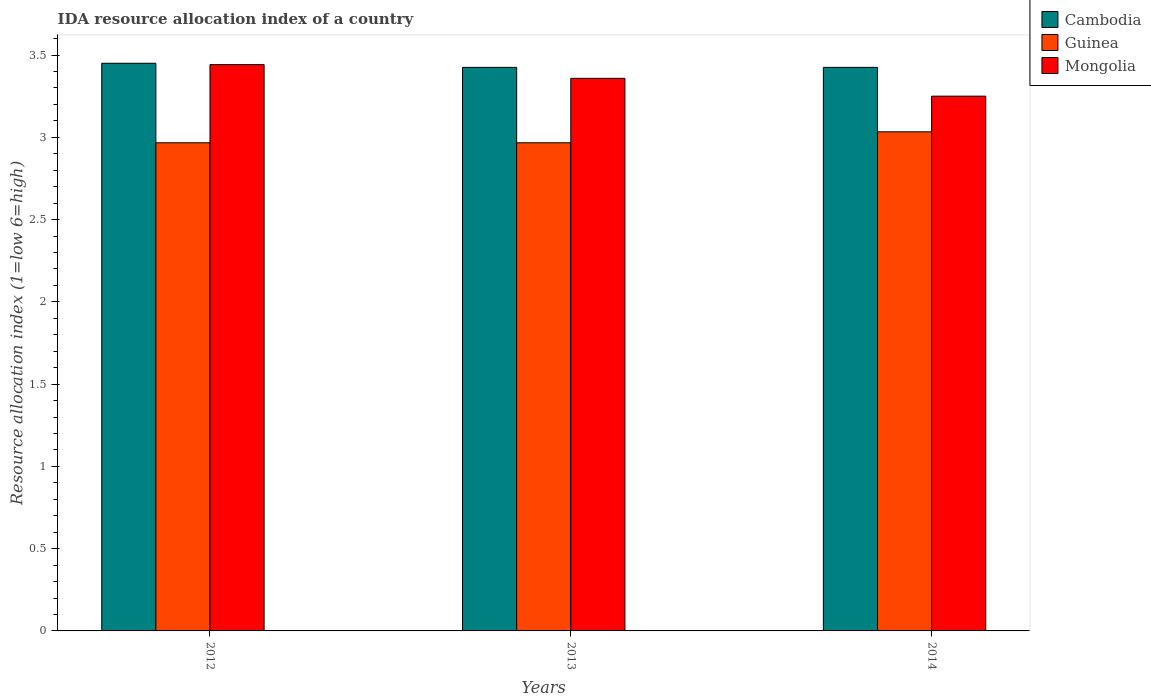How many different coloured bars are there?
Give a very brief answer. 3. Are the number of bars on each tick of the X-axis equal?
Offer a terse response. Yes. How many bars are there on the 3rd tick from the left?
Offer a terse response. 3. How many bars are there on the 2nd tick from the right?
Give a very brief answer. 3. In how many cases, is the number of bars for a given year not equal to the number of legend labels?
Your answer should be very brief. 0. What is the IDA resource allocation index in Cambodia in 2013?
Make the answer very short. 3.42. Across all years, what is the maximum IDA resource allocation index in Guinea?
Your answer should be compact. 3.03. What is the total IDA resource allocation index in Guinea in the graph?
Your response must be concise. 8.97. What is the difference between the IDA resource allocation index in Mongolia in 2012 and that in 2014?
Your answer should be compact. 0.19. What is the difference between the IDA resource allocation index in Guinea in 2014 and the IDA resource allocation index in Cambodia in 2012?
Your answer should be very brief. -0.42. What is the average IDA resource allocation index in Cambodia per year?
Your answer should be compact. 3.43. In the year 2013, what is the difference between the IDA resource allocation index in Mongolia and IDA resource allocation index in Cambodia?
Your response must be concise. -0.07. What is the ratio of the IDA resource allocation index in Guinea in 2012 to that in 2013?
Give a very brief answer. 1. Is the IDA resource allocation index in Mongolia in 2012 less than that in 2013?
Your answer should be compact. No. What is the difference between the highest and the second highest IDA resource allocation index in Mongolia?
Make the answer very short. 0.08. What is the difference between the highest and the lowest IDA resource allocation index in Guinea?
Offer a very short reply. 0.07. In how many years, is the IDA resource allocation index in Mongolia greater than the average IDA resource allocation index in Mongolia taken over all years?
Offer a terse response. 2. Is the sum of the IDA resource allocation index in Mongolia in 2013 and 2014 greater than the maximum IDA resource allocation index in Cambodia across all years?
Your answer should be very brief. Yes. What does the 2nd bar from the left in 2014 represents?
Keep it short and to the point. Guinea. What does the 1st bar from the right in 2012 represents?
Provide a short and direct response. Mongolia. Is it the case that in every year, the sum of the IDA resource allocation index in Guinea and IDA resource allocation index in Cambodia is greater than the IDA resource allocation index in Mongolia?
Provide a succinct answer. Yes. Does the graph contain grids?
Offer a very short reply. No. Where does the legend appear in the graph?
Your response must be concise. Top right. How many legend labels are there?
Offer a very short reply. 3. What is the title of the graph?
Your response must be concise. IDA resource allocation index of a country. Does "Guatemala" appear as one of the legend labels in the graph?
Offer a terse response. No. What is the label or title of the X-axis?
Make the answer very short. Years. What is the label or title of the Y-axis?
Ensure brevity in your answer.  Resource allocation index (1=low 6=high). What is the Resource allocation index (1=low 6=high) of Cambodia in 2012?
Your response must be concise. 3.45. What is the Resource allocation index (1=low 6=high) in Guinea in 2012?
Make the answer very short. 2.97. What is the Resource allocation index (1=low 6=high) of Mongolia in 2012?
Keep it short and to the point. 3.44. What is the Resource allocation index (1=low 6=high) in Cambodia in 2013?
Provide a succinct answer. 3.42. What is the Resource allocation index (1=low 6=high) in Guinea in 2013?
Keep it short and to the point. 2.97. What is the Resource allocation index (1=low 6=high) in Mongolia in 2013?
Offer a terse response. 3.36. What is the Resource allocation index (1=low 6=high) in Cambodia in 2014?
Your answer should be very brief. 3.42. What is the Resource allocation index (1=low 6=high) in Guinea in 2014?
Give a very brief answer. 3.03. Across all years, what is the maximum Resource allocation index (1=low 6=high) in Cambodia?
Give a very brief answer. 3.45. Across all years, what is the maximum Resource allocation index (1=low 6=high) in Guinea?
Your answer should be very brief. 3.03. Across all years, what is the maximum Resource allocation index (1=low 6=high) of Mongolia?
Your response must be concise. 3.44. Across all years, what is the minimum Resource allocation index (1=low 6=high) in Cambodia?
Give a very brief answer. 3.42. Across all years, what is the minimum Resource allocation index (1=low 6=high) of Guinea?
Your response must be concise. 2.97. Across all years, what is the minimum Resource allocation index (1=low 6=high) in Mongolia?
Offer a terse response. 3.25. What is the total Resource allocation index (1=low 6=high) in Guinea in the graph?
Your answer should be very brief. 8.97. What is the total Resource allocation index (1=low 6=high) in Mongolia in the graph?
Offer a terse response. 10.05. What is the difference between the Resource allocation index (1=low 6=high) of Cambodia in 2012 and that in 2013?
Ensure brevity in your answer.  0.03. What is the difference between the Resource allocation index (1=low 6=high) of Mongolia in 2012 and that in 2013?
Ensure brevity in your answer.  0.08. What is the difference between the Resource allocation index (1=low 6=high) in Cambodia in 2012 and that in 2014?
Make the answer very short. 0.03. What is the difference between the Resource allocation index (1=low 6=high) of Guinea in 2012 and that in 2014?
Your answer should be very brief. -0.07. What is the difference between the Resource allocation index (1=low 6=high) in Mongolia in 2012 and that in 2014?
Offer a very short reply. 0.19. What is the difference between the Resource allocation index (1=low 6=high) of Guinea in 2013 and that in 2014?
Make the answer very short. -0.07. What is the difference between the Resource allocation index (1=low 6=high) of Mongolia in 2013 and that in 2014?
Your answer should be compact. 0.11. What is the difference between the Resource allocation index (1=low 6=high) of Cambodia in 2012 and the Resource allocation index (1=low 6=high) of Guinea in 2013?
Ensure brevity in your answer.  0.48. What is the difference between the Resource allocation index (1=low 6=high) of Cambodia in 2012 and the Resource allocation index (1=low 6=high) of Mongolia in 2013?
Your response must be concise. 0.09. What is the difference between the Resource allocation index (1=low 6=high) in Guinea in 2012 and the Resource allocation index (1=low 6=high) in Mongolia in 2013?
Offer a very short reply. -0.39. What is the difference between the Resource allocation index (1=low 6=high) in Cambodia in 2012 and the Resource allocation index (1=low 6=high) in Guinea in 2014?
Ensure brevity in your answer.  0.42. What is the difference between the Resource allocation index (1=low 6=high) of Cambodia in 2012 and the Resource allocation index (1=low 6=high) of Mongolia in 2014?
Your answer should be very brief. 0.2. What is the difference between the Resource allocation index (1=low 6=high) in Guinea in 2012 and the Resource allocation index (1=low 6=high) in Mongolia in 2014?
Offer a terse response. -0.28. What is the difference between the Resource allocation index (1=low 6=high) of Cambodia in 2013 and the Resource allocation index (1=low 6=high) of Guinea in 2014?
Your answer should be compact. 0.39. What is the difference between the Resource allocation index (1=low 6=high) of Cambodia in 2013 and the Resource allocation index (1=low 6=high) of Mongolia in 2014?
Your answer should be compact. 0.17. What is the difference between the Resource allocation index (1=low 6=high) in Guinea in 2013 and the Resource allocation index (1=low 6=high) in Mongolia in 2014?
Your response must be concise. -0.28. What is the average Resource allocation index (1=low 6=high) of Cambodia per year?
Your response must be concise. 3.43. What is the average Resource allocation index (1=low 6=high) in Guinea per year?
Offer a terse response. 2.99. What is the average Resource allocation index (1=low 6=high) of Mongolia per year?
Give a very brief answer. 3.35. In the year 2012, what is the difference between the Resource allocation index (1=low 6=high) in Cambodia and Resource allocation index (1=low 6=high) in Guinea?
Keep it short and to the point. 0.48. In the year 2012, what is the difference between the Resource allocation index (1=low 6=high) in Cambodia and Resource allocation index (1=low 6=high) in Mongolia?
Offer a very short reply. 0.01. In the year 2012, what is the difference between the Resource allocation index (1=low 6=high) in Guinea and Resource allocation index (1=low 6=high) in Mongolia?
Provide a short and direct response. -0.47. In the year 2013, what is the difference between the Resource allocation index (1=low 6=high) in Cambodia and Resource allocation index (1=low 6=high) in Guinea?
Provide a short and direct response. 0.46. In the year 2013, what is the difference between the Resource allocation index (1=low 6=high) of Cambodia and Resource allocation index (1=low 6=high) of Mongolia?
Give a very brief answer. 0.07. In the year 2013, what is the difference between the Resource allocation index (1=low 6=high) of Guinea and Resource allocation index (1=low 6=high) of Mongolia?
Provide a succinct answer. -0.39. In the year 2014, what is the difference between the Resource allocation index (1=low 6=high) in Cambodia and Resource allocation index (1=low 6=high) in Guinea?
Give a very brief answer. 0.39. In the year 2014, what is the difference between the Resource allocation index (1=low 6=high) in Cambodia and Resource allocation index (1=low 6=high) in Mongolia?
Ensure brevity in your answer.  0.17. In the year 2014, what is the difference between the Resource allocation index (1=low 6=high) of Guinea and Resource allocation index (1=low 6=high) of Mongolia?
Offer a terse response. -0.22. What is the ratio of the Resource allocation index (1=low 6=high) in Cambodia in 2012 to that in 2013?
Make the answer very short. 1.01. What is the ratio of the Resource allocation index (1=low 6=high) of Mongolia in 2012 to that in 2013?
Your response must be concise. 1.02. What is the ratio of the Resource allocation index (1=low 6=high) in Cambodia in 2012 to that in 2014?
Ensure brevity in your answer.  1.01. What is the ratio of the Resource allocation index (1=low 6=high) of Mongolia in 2012 to that in 2014?
Offer a terse response. 1.06. What is the ratio of the Resource allocation index (1=low 6=high) in Guinea in 2013 to that in 2014?
Ensure brevity in your answer.  0.98. What is the difference between the highest and the second highest Resource allocation index (1=low 6=high) of Cambodia?
Give a very brief answer. 0.03. What is the difference between the highest and the second highest Resource allocation index (1=low 6=high) in Guinea?
Your answer should be very brief. 0.07. What is the difference between the highest and the second highest Resource allocation index (1=low 6=high) in Mongolia?
Provide a succinct answer. 0.08. What is the difference between the highest and the lowest Resource allocation index (1=low 6=high) in Cambodia?
Keep it short and to the point. 0.03. What is the difference between the highest and the lowest Resource allocation index (1=low 6=high) in Guinea?
Make the answer very short. 0.07. What is the difference between the highest and the lowest Resource allocation index (1=low 6=high) of Mongolia?
Offer a terse response. 0.19. 